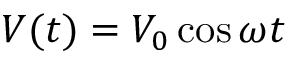<formula> <loc_0><loc_0><loc_500><loc_500>V ( t ) = V _ { 0 } \cos \omega t</formula> 